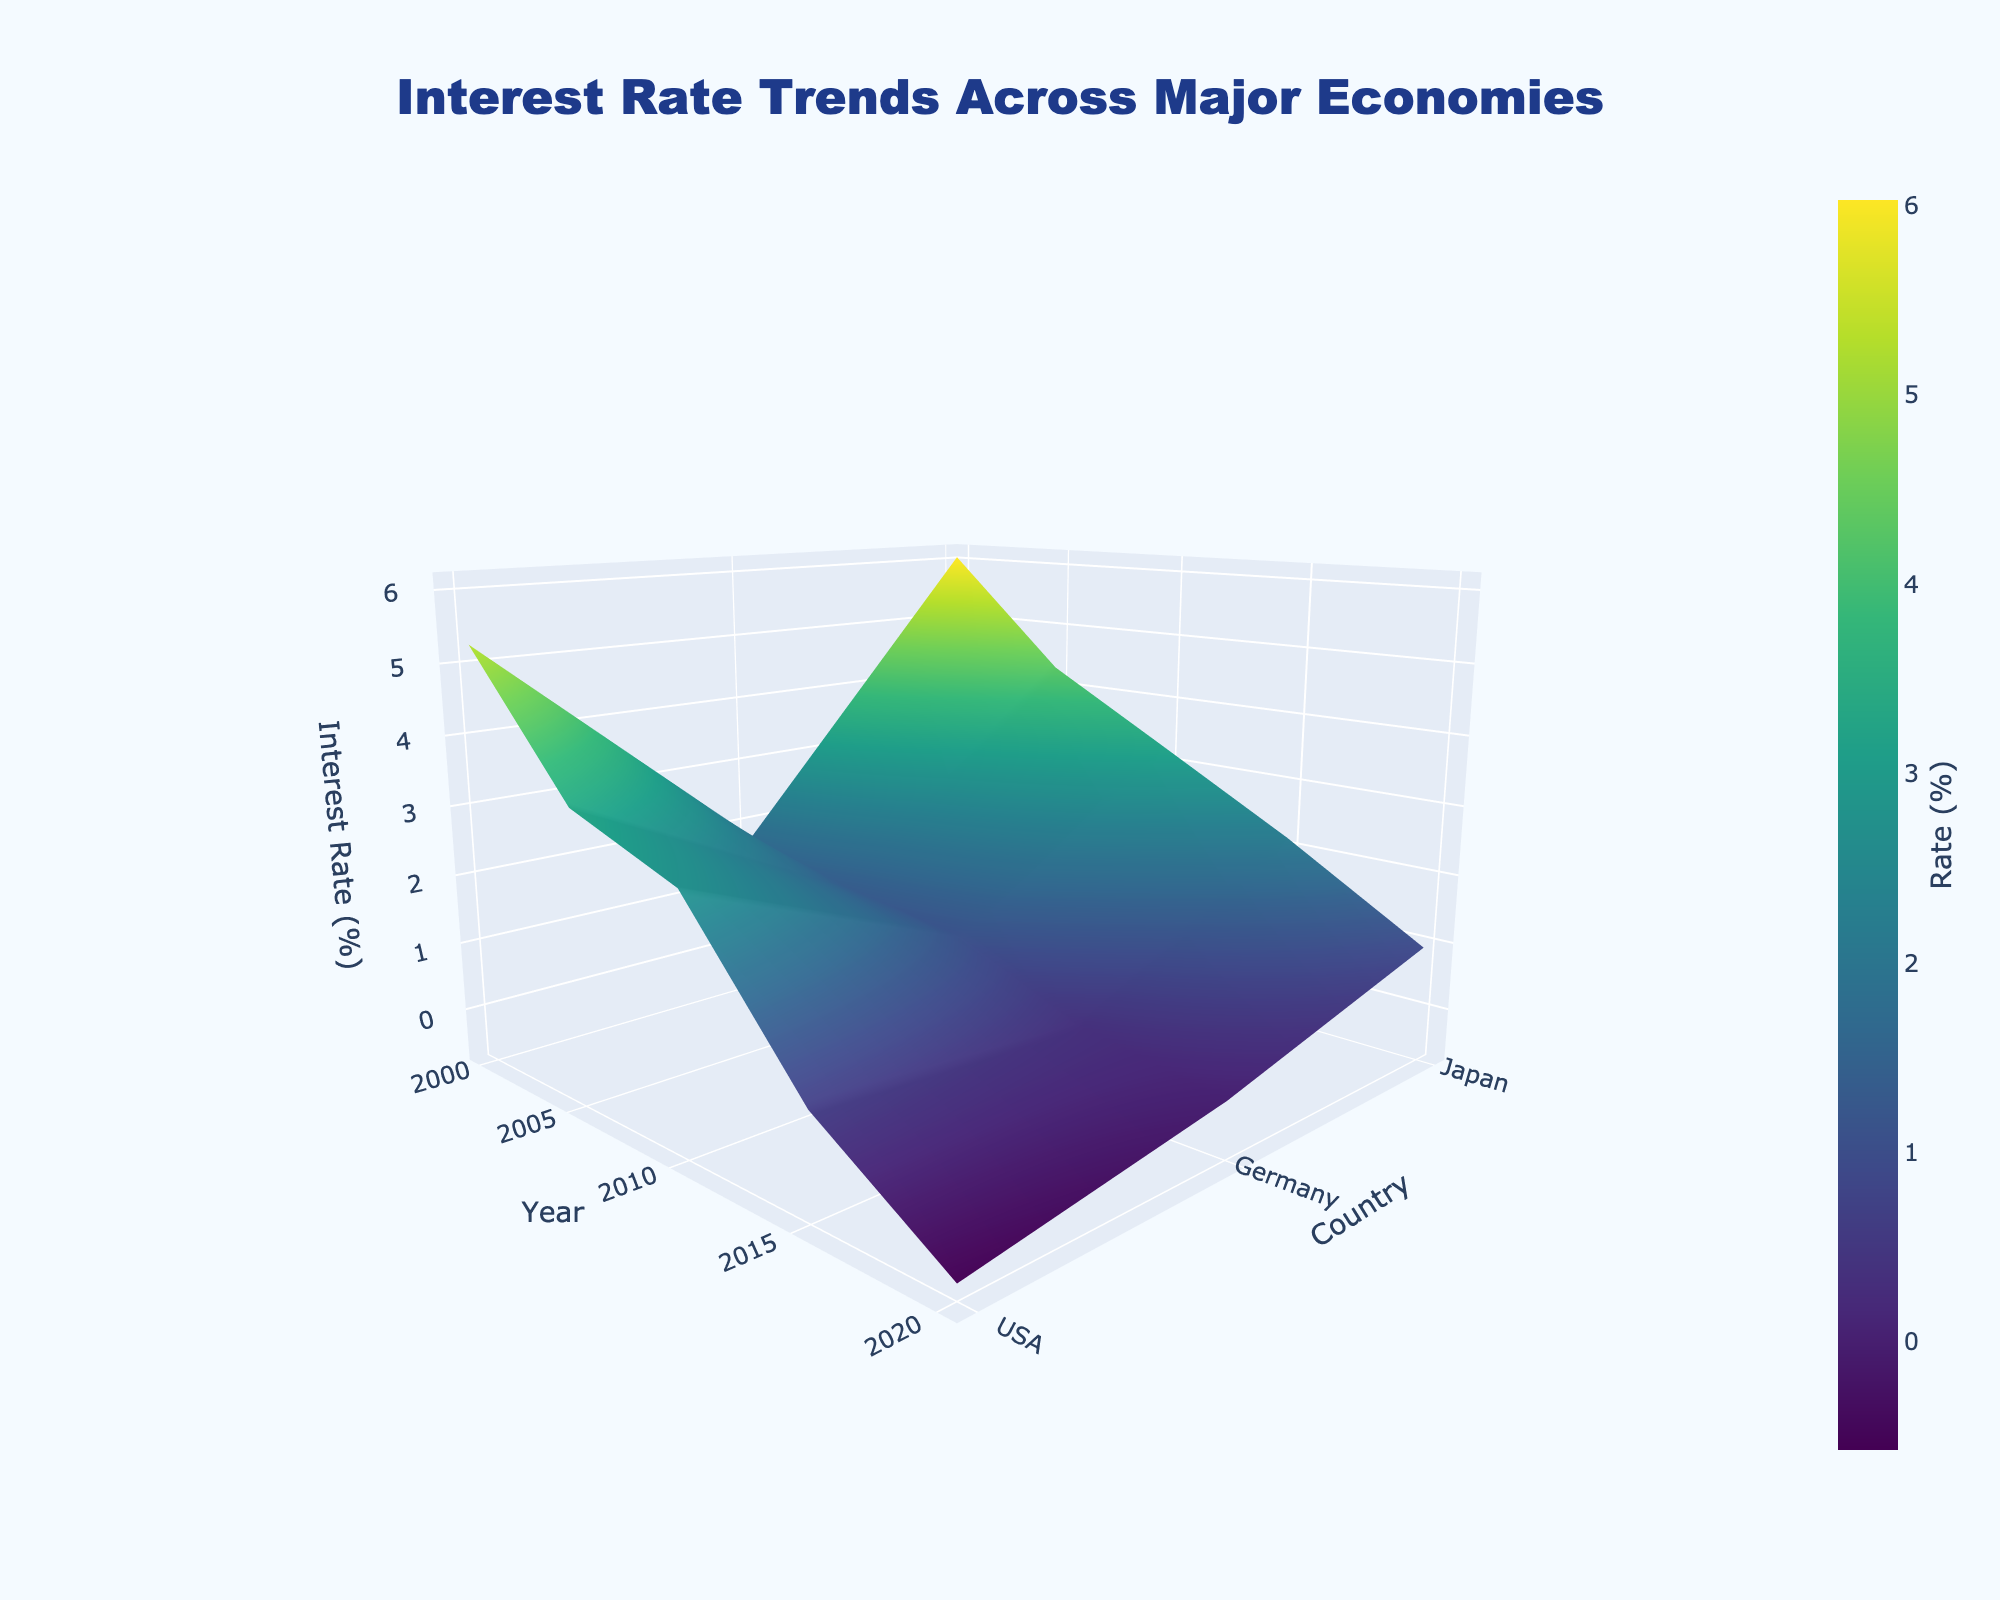what is the title of the plot? The title is positioned at the top center of the plot. It is a short description that summarizes what the plot is illustrating.
Answer: Interest Rate Trends Across Major Economies What are the labels for the x-axis, y-axis, and z-axis? The axis labels indicate the type of data plotted on each axis: the x-axis label is towards the bottom, the y-axis label is on the left side, and the z-axis label is along the vertical axis.
Answer: Year, Country, Interest Rate (%) Which country's 10-Year financial instrument had the highest interest rate in 2000? By examining the highest peak on the plot for the year 2000, we can identify which country's financial instrument had the highest interest rate.
Answer: USA How did Japan's 10-Year JGB rates change from 2000 to 2020? Follow the color gradient or the relative position of Japan's interest rates on the z-axis from the year 2000 to 2020 to observe the trend over time.
Answer: Decreased What is the difference in interest rates between Germany and Japan in 2020? Locate the interest rate for Germany and Japan in 2020 on the y-axis. Subtract the value for Japan from the value for Germany to find the difference.
Answer: -0.59% Which country showed the most consistent interest rate trend over the years and how can you tell? Look for the country with the least variation (smoothest surface) in interest rates over the plotted years, indicating stability.
Answer: Japan Among the three countries, which one had the lowest interest rate in 2015, and what was it? Identify the lowest point on the plot for the year 2015 among the three countries.
Answer: Germany, 0.63% On average, which country had the highest interest rates over the years 2000 to 2020? Calculate the average rate by summing the interest rates for each country over the years and dividing by the number of years to compare the averages.
Answer: USA 